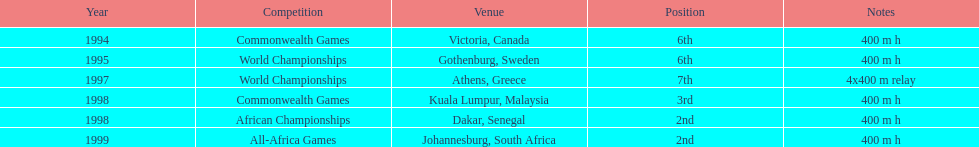Can you provide the name of the final contest? All-Africa Games. 